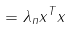<formula> <loc_0><loc_0><loc_500><loc_500>= \lambda _ { n } x ^ { T } x</formula> 